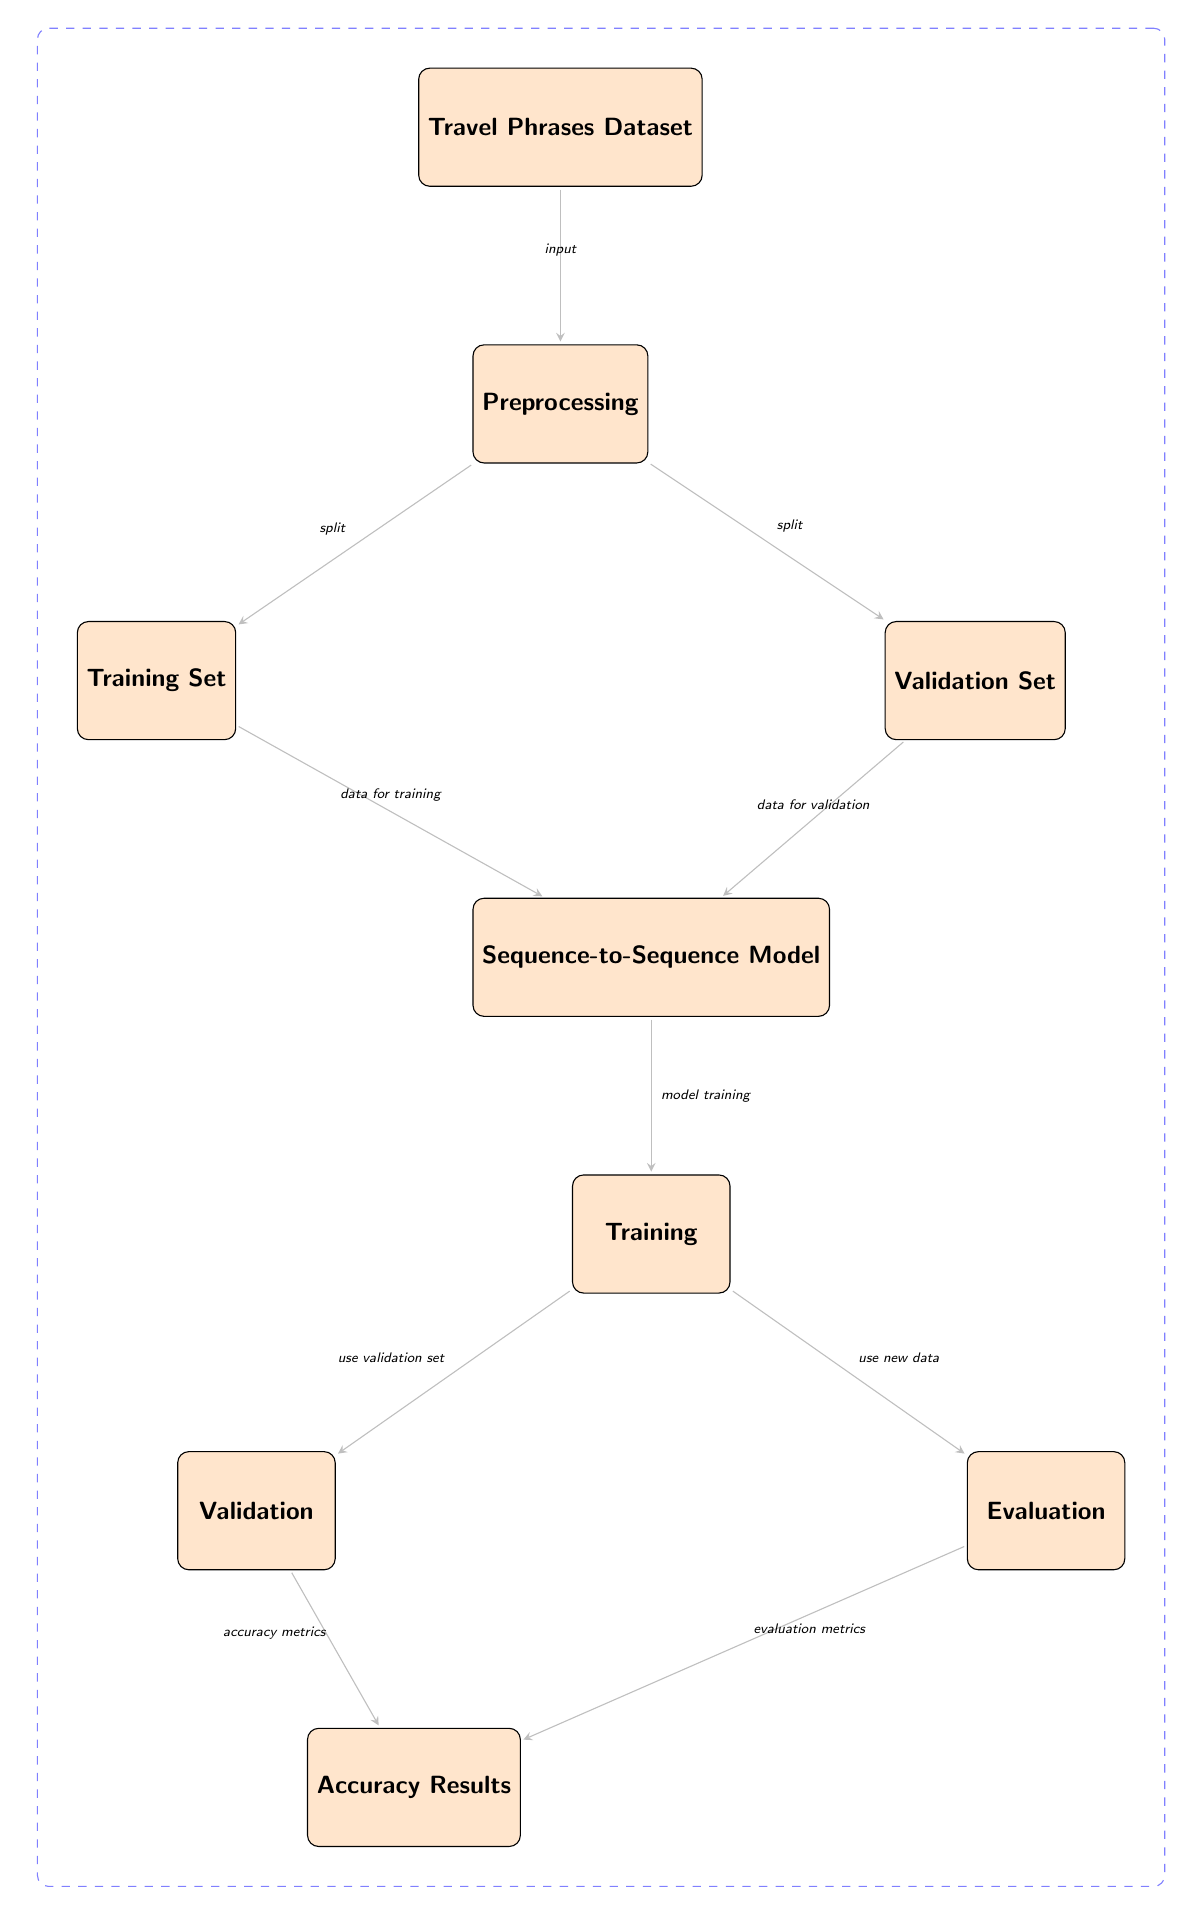What is the input to the diagram? The diagram starts with a node labeled "Travel Phrases Dataset" which represents the input to the entire process.
Answer: Travel Phrases Dataset How many main nodes are present in the diagram? By counting the distinct nodes, there are nine main nodes in the diagram representing various stages of the process.
Answer: Nine Which node represents the final stage of the process? The last node in the sequence, positioned at the bottom of the diagram, is labeled "Accuracy Results," indicating the end stage of the process.
Answer: Accuracy Results What is the relationship between the "Training Set" and the "Sequence-to-Sequence Model"? The "Training Set" node sends data directly to the "Sequence-to-Sequence Model" node as indicated by the edge showing the direction of data flow.
Answer: Data for training What is the purpose of the "Validation" node? The "Validation" node is used to evaluate the performance of the model during the training process, thus helping to refine the model's accuracy.
Answer: Use validation set How does "Evaluation" relate to "Accuracy Results"? The "Evaluation" node feeds into "Accuracy Results," meaning the evaluation metrics contribute to determining the overall accuracy of the translated phrases.
Answer: Evaluation metrics What is the primary output of the diagram? The final output of the entire process, as indicated in the last node, is the "Accuracy Results" which provides insights into the translation accuracy.
Answer: Accuracy Results Which two nodes represent the initial steps of data preparation? The two initial steps in the diagram labeled "Preprocessing," followed by splitting into "Training Set" and "Validation Set," are vital in preparing the data for modeling.
Answer: Preprocessing and split What specific role does the "Training" node play in this process? The "Training" node is where the model is trained using the prepared datasets, focusing on improving its ability to translate travel phrases accurately.
Answer: Model training 